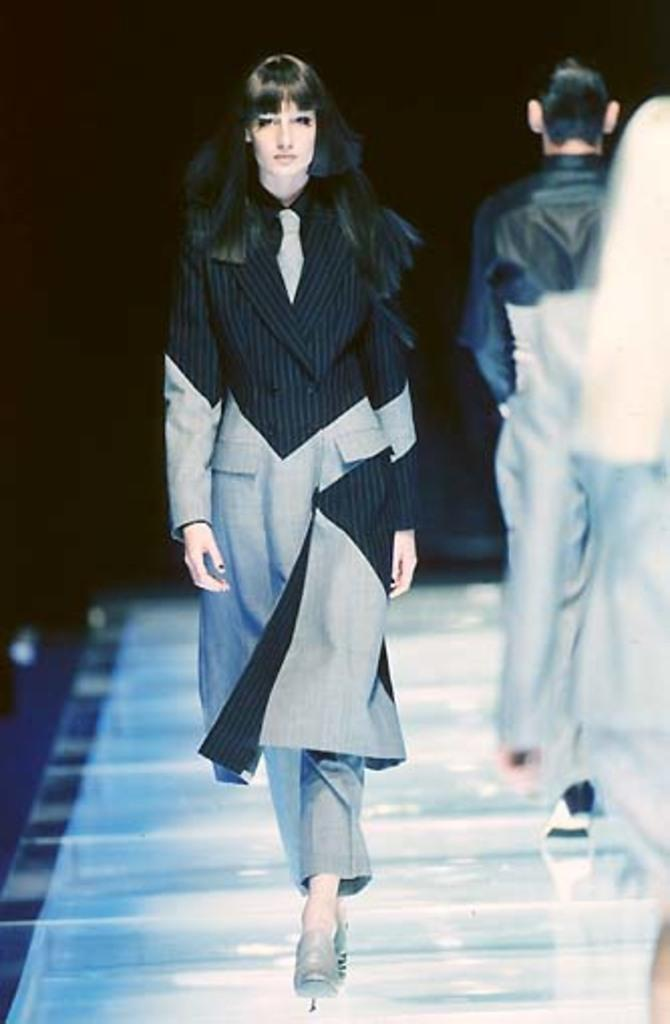What is the woman in the image doing? The woman is walking on a platform in the image. Are there any other people present on the platform? Yes, there are people standing on the platform in the image. What can be observed about the background of the image? The background of the image is dark. What type of rings can be seen on the woman's fingers in the image? There are no rings visible on the woman's fingers in the image. Can you see any airplanes flying in the background of the image? There is no mention of an airplane in the image, so it cannot be determined if any are present. 